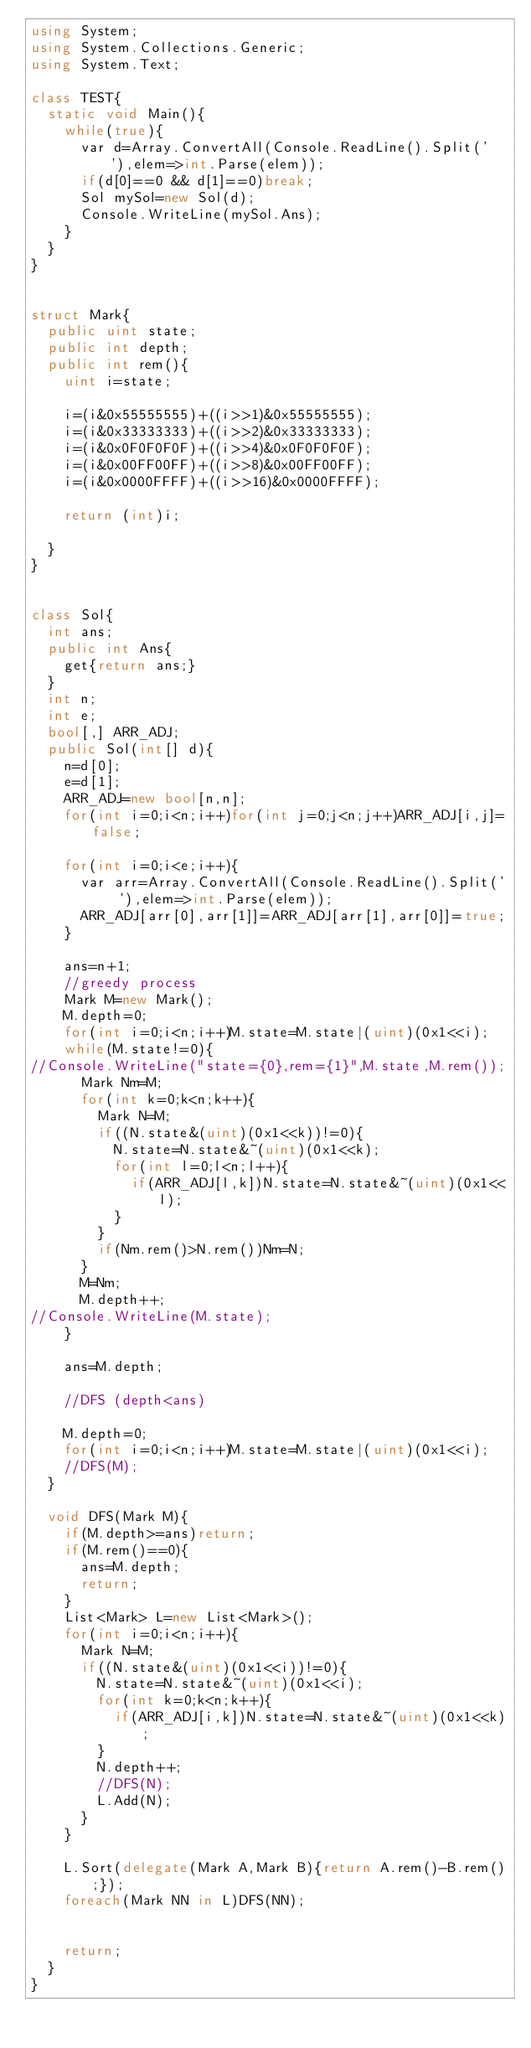Convert code to text. <code><loc_0><loc_0><loc_500><loc_500><_C#_>using System;
using System.Collections.Generic;
using System.Text;

class TEST{
	static void Main(){
		while(true){
			var d=Array.ConvertAll(Console.ReadLine().Split(' '),elem=>int.Parse(elem));
			if(d[0]==0 && d[1]==0)break;
			Sol mySol=new Sol(d);
			Console.WriteLine(mySol.Ans);
		}
	}
}


struct Mark{
	public uint state;
	public int depth;
	public int rem(){
		uint i=state;
		
		i=(i&0x55555555)+((i>>1)&0x55555555);
		i=(i&0x33333333)+((i>>2)&0x33333333);
		i=(i&0x0F0F0F0F)+((i>>4)&0x0F0F0F0F);
		i=(i&0x00FF00FF)+((i>>8)&0x00FF00FF);
		i=(i&0x0000FFFF)+((i>>16)&0x0000FFFF);
		
		return (int)i;
		
	}
}


class Sol{
	int ans;
	public int Ans{
		get{return ans;}
	}
	int n;
	int e;
	bool[,] ARR_ADJ;
	public Sol(int[] d){
		n=d[0];
		e=d[1];
		ARR_ADJ=new bool[n,n];
		for(int i=0;i<n;i++)for(int j=0;j<n;j++)ARR_ADJ[i,j]=false;
		
		for(int i=0;i<e;i++){
			var arr=Array.ConvertAll(Console.ReadLine().Split(' '),elem=>int.Parse(elem));
			ARR_ADJ[arr[0],arr[1]]=ARR_ADJ[arr[1],arr[0]]=true;
		}
		
		ans=n+1;
		//greedy process
		Mark M=new Mark();
		M.depth=0;
		for(int i=0;i<n;i++)M.state=M.state|(uint)(0x1<<i);
		while(M.state!=0){
//Console.WriteLine("state={0},rem={1}",M.state,M.rem());
			Mark Nm=M;
			for(int k=0;k<n;k++){
				Mark N=M;
				if((N.state&(uint)(0x1<<k))!=0){
					N.state=N.state&~(uint)(0x1<<k);
					for(int l=0;l<n;l++){
						if(ARR_ADJ[l,k])N.state=N.state&~(uint)(0x1<<l);
					}
				}
				if(Nm.rem()>N.rem())Nm=N;
			}
			M=Nm;
			M.depth++;
//Console.WriteLine(M.state);
		}
		
		ans=M.depth;
		
		//DFS (depth<ans)
		
		M.depth=0;
		for(int i=0;i<n;i++)M.state=M.state|(uint)(0x1<<i);
		//DFS(M);
	}
	
	void DFS(Mark M){
		if(M.depth>=ans)return;
		if(M.rem()==0){
			ans=M.depth;
			return;
		}
		List<Mark> L=new List<Mark>();
		for(int i=0;i<n;i++){
			Mark N=M;
			if((N.state&(uint)(0x1<<i))!=0){
				N.state=N.state&~(uint)(0x1<<i);
				for(int k=0;k<n;k++){
					if(ARR_ADJ[i,k])N.state=N.state&~(uint)(0x1<<k);
				}
				N.depth++;
				//DFS(N);
				L.Add(N);
			}
		}
		
		L.Sort(delegate(Mark A,Mark B){return A.rem()-B.rem();});
		foreach(Mark NN in L)DFS(NN);
		
		
		return;
	}
}</code> 